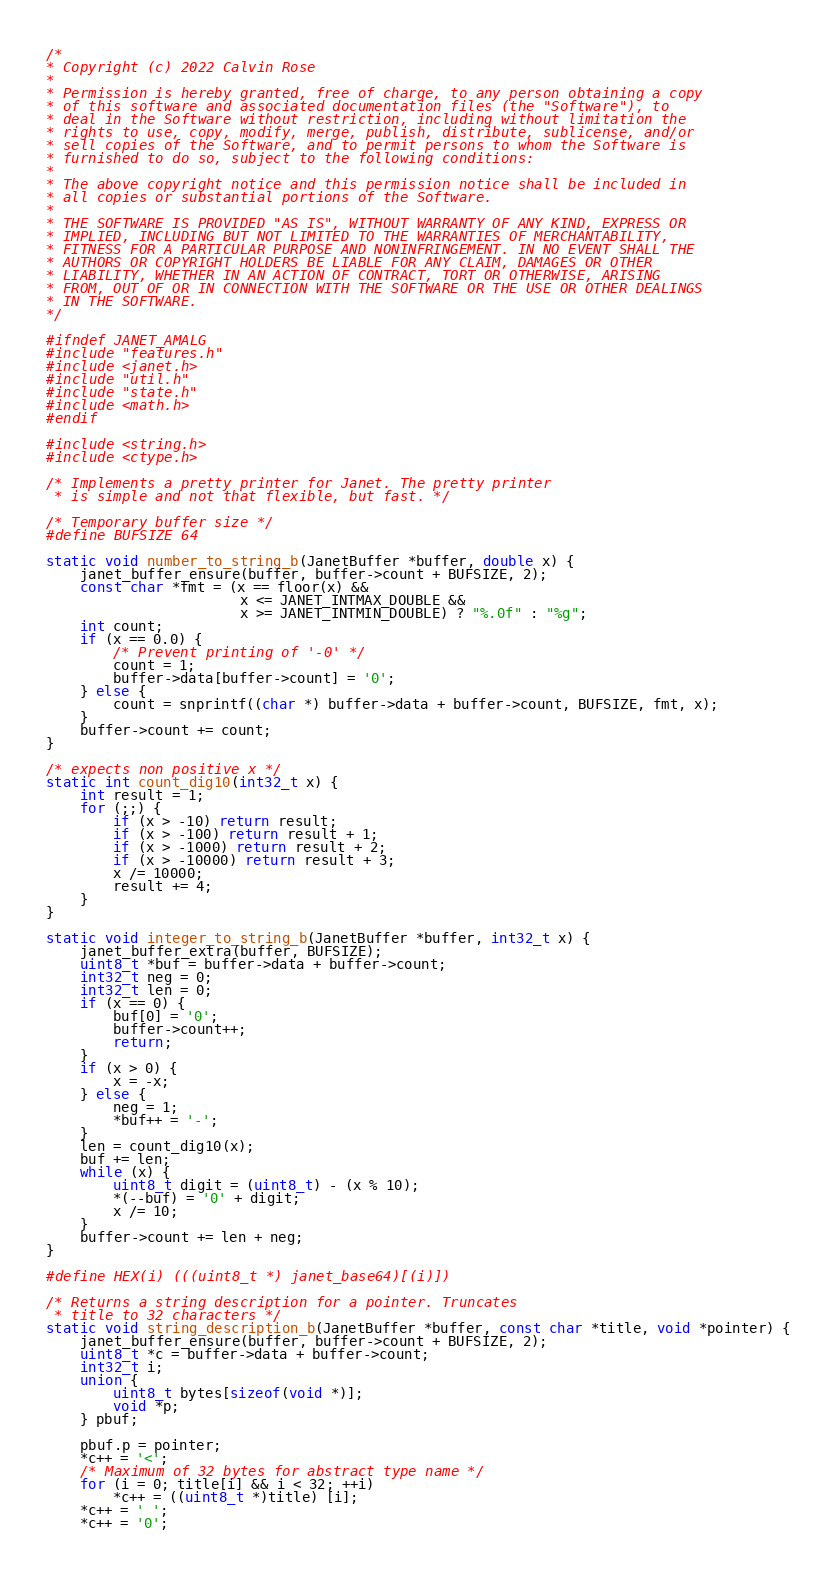Convert code to text. <code><loc_0><loc_0><loc_500><loc_500><_C_>/*
* Copyright (c) 2022 Calvin Rose
*
* Permission is hereby granted, free of charge, to any person obtaining a copy
* of this software and associated documentation files (the "Software"), to
* deal in the Software without restriction, including without limitation the
* rights to use, copy, modify, merge, publish, distribute, sublicense, and/or
* sell copies of the Software, and to permit persons to whom the Software is
* furnished to do so, subject to the following conditions:
*
* The above copyright notice and this permission notice shall be included in
* all copies or substantial portions of the Software.
*
* THE SOFTWARE IS PROVIDED "AS IS", WITHOUT WARRANTY OF ANY KIND, EXPRESS OR
* IMPLIED, INCLUDING BUT NOT LIMITED TO THE WARRANTIES OF MERCHANTABILITY,
* FITNESS FOR A PARTICULAR PURPOSE AND NONINFRINGEMENT. IN NO EVENT SHALL THE
* AUTHORS OR COPYRIGHT HOLDERS BE LIABLE FOR ANY CLAIM, DAMAGES OR OTHER
* LIABILITY, WHETHER IN AN ACTION OF CONTRACT, TORT OR OTHERWISE, ARISING
* FROM, OUT OF OR IN CONNECTION WITH THE SOFTWARE OR THE USE OR OTHER DEALINGS
* IN THE SOFTWARE.
*/

#ifndef JANET_AMALG
#include "features.h"
#include <janet.h>
#include "util.h"
#include "state.h"
#include <math.h>
#endif

#include <string.h>
#include <ctype.h>

/* Implements a pretty printer for Janet. The pretty printer
 * is simple and not that flexible, but fast. */

/* Temporary buffer size */
#define BUFSIZE 64

static void number_to_string_b(JanetBuffer *buffer, double x) {
    janet_buffer_ensure(buffer, buffer->count + BUFSIZE, 2);
    const char *fmt = (x == floor(x) &&
                       x <= JANET_INTMAX_DOUBLE &&
                       x >= JANET_INTMIN_DOUBLE) ? "%.0f" : "%g";
    int count;
    if (x == 0.0) {
        /* Prevent printing of '-0' */
        count = 1;
        buffer->data[buffer->count] = '0';
    } else {
        count = snprintf((char *) buffer->data + buffer->count, BUFSIZE, fmt, x);
    }
    buffer->count += count;
}

/* expects non positive x */
static int count_dig10(int32_t x) {
    int result = 1;
    for (;;) {
        if (x > -10) return result;
        if (x > -100) return result + 1;
        if (x > -1000) return result + 2;
        if (x > -10000) return result + 3;
        x /= 10000;
        result += 4;
    }
}

static void integer_to_string_b(JanetBuffer *buffer, int32_t x) {
    janet_buffer_extra(buffer, BUFSIZE);
    uint8_t *buf = buffer->data + buffer->count;
    int32_t neg = 0;
    int32_t len = 0;
    if (x == 0) {
        buf[0] = '0';
        buffer->count++;
        return;
    }
    if (x > 0) {
        x = -x;
    } else {
        neg = 1;
        *buf++ = '-';
    }
    len = count_dig10(x);
    buf += len;
    while (x) {
        uint8_t digit = (uint8_t) - (x % 10);
        *(--buf) = '0' + digit;
        x /= 10;
    }
    buffer->count += len + neg;
}

#define HEX(i) (((uint8_t *) janet_base64)[(i)])

/* Returns a string description for a pointer. Truncates
 * title to 32 characters */
static void string_description_b(JanetBuffer *buffer, const char *title, void *pointer) {
    janet_buffer_ensure(buffer, buffer->count + BUFSIZE, 2);
    uint8_t *c = buffer->data + buffer->count;
    int32_t i;
    union {
        uint8_t bytes[sizeof(void *)];
        void *p;
    } pbuf;

    pbuf.p = pointer;
    *c++ = '<';
    /* Maximum of 32 bytes for abstract type name */
    for (i = 0; title[i] && i < 32; ++i)
        *c++ = ((uint8_t *)title) [i];
    *c++ = ' ';
    *c++ = '0';</code> 